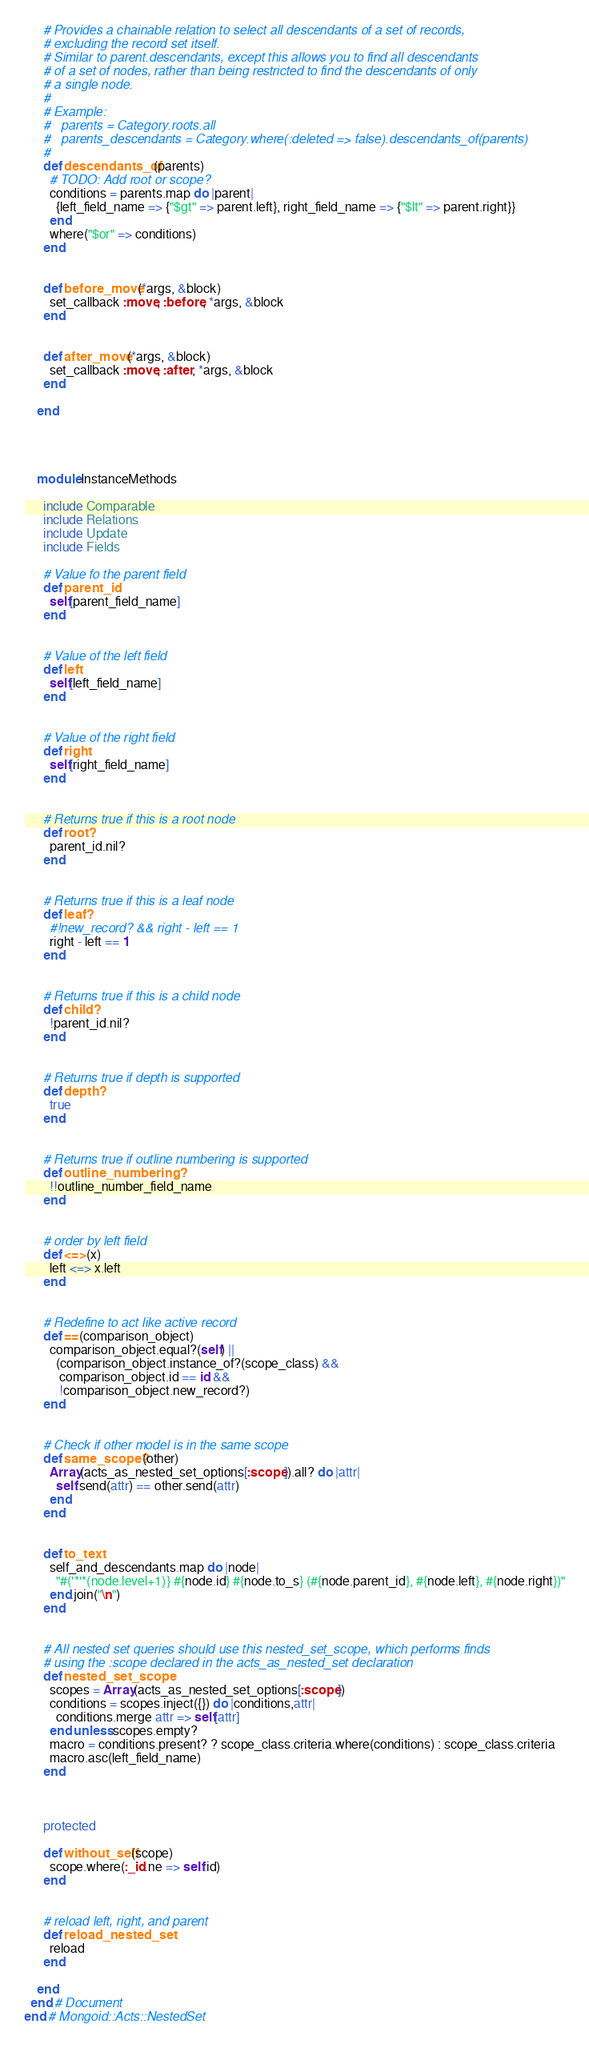<code> <loc_0><loc_0><loc_500><loc_500><_Ruby_>
      # Provides a chainable relation to select all descendants of a set of records,
      # excluding the record set itself.
      # Similar to parent.descendants, except this allows you to find all descendants
      # of a set of nodes, rather than being restricted to find the descendants of only
      # a single node.
      #
      # Example:
      #   parents = Category.roots.all
      #   parents_descendants = Category.where(:deleted => false).descendants_of(parents)
      #
      def descendants_of(parents)
        # TODO: Add root or scope?
        conditions = parents.map do |parent|
          {left_field_name => {"$gt" => parent.left}, right_field_name => {"$lt" => parent.right}}
        end
        where("$or" => conditions)
      end


      def before_move(*args, &block)
        set_callback :move, :before, *args, &block
      end


      def after_move(*args, &block)
        set_callback :move, :after, *args, &block
      end

    end




    module InstanceMethods

      include Comparable
      include Relations
      include Update
      include Fields

      # Value fo the parent field
      def parent_id
        self[parent_field_name]
      end


      # Value of the left field
      def left
        self[left_field_name]
      end


      # Value of the right field
      def right
        self[right_field_name]
      end


      # Returns true if this is a root node
      def root?
        parent_id.nil?
      end


      # Returns true if this is a leaf node
      def leaf?
        #!new_record? && right - left == 1
        right - left == 1
      end


      # Returns true if this is a child node
      def child?
        !parent_id.nil?
      end


      # Returns true if depth is supported
      def depth?
        true
      end


      # Returns true if outline numbering is supported
      def outline_numbering?
        !!outline_number_field_name
      end


      # order by left field
      def <=>(x)
        left <=> x.left
      end


      # Redefine to act like active record
      def ==(comparison_object)
        comparison_object.equal?(self) ||
          (comparison_object.instance_of?(scope_class) &&
           comparison_object.id == id &&
           !comparison_object.new_record?)
      end


      # Check if other model is in the same scope
      def same_scope?(other)
        Array(acts_as_nested_set_options[:scope]).all? do |attr|
          self.send(attr) == other.send(attr)
        end
      end


      def to_text
        self_and_descendants.map do |node|
          "#('*'*(node.level+1)} #{node.id} #{node.to_s} (#{node.parent_id}, #{node.left}, #{node.right})"
        end.join("\n")
      end


      # All nested set queries should use this nested_set_scope, which performs finds
      # using the :scope declared in the acts_as_nested_set declaration
      def nested_set_scope
        scopes = Array(acts_as_nested_set_options[:scope])
        conditions = scopes.inject({}) do |conditions,attr|
          conditions.merge attr => self[attr]
        end unless scopes.empty?
        macro = conditions.present? ? scope_class.criteria.where(conditions) : scope_class.criteria
        macro.asc(left_field_name)
      end



      protected

      def without_self(scope)
        scope.where(:_id.ne => self.id)
      end


      # reload left, right, and parent
      def reload_nested_set
        reload
      end

    end
  end # Document
end # Mongoid::Acts::NestedSet
</code> 